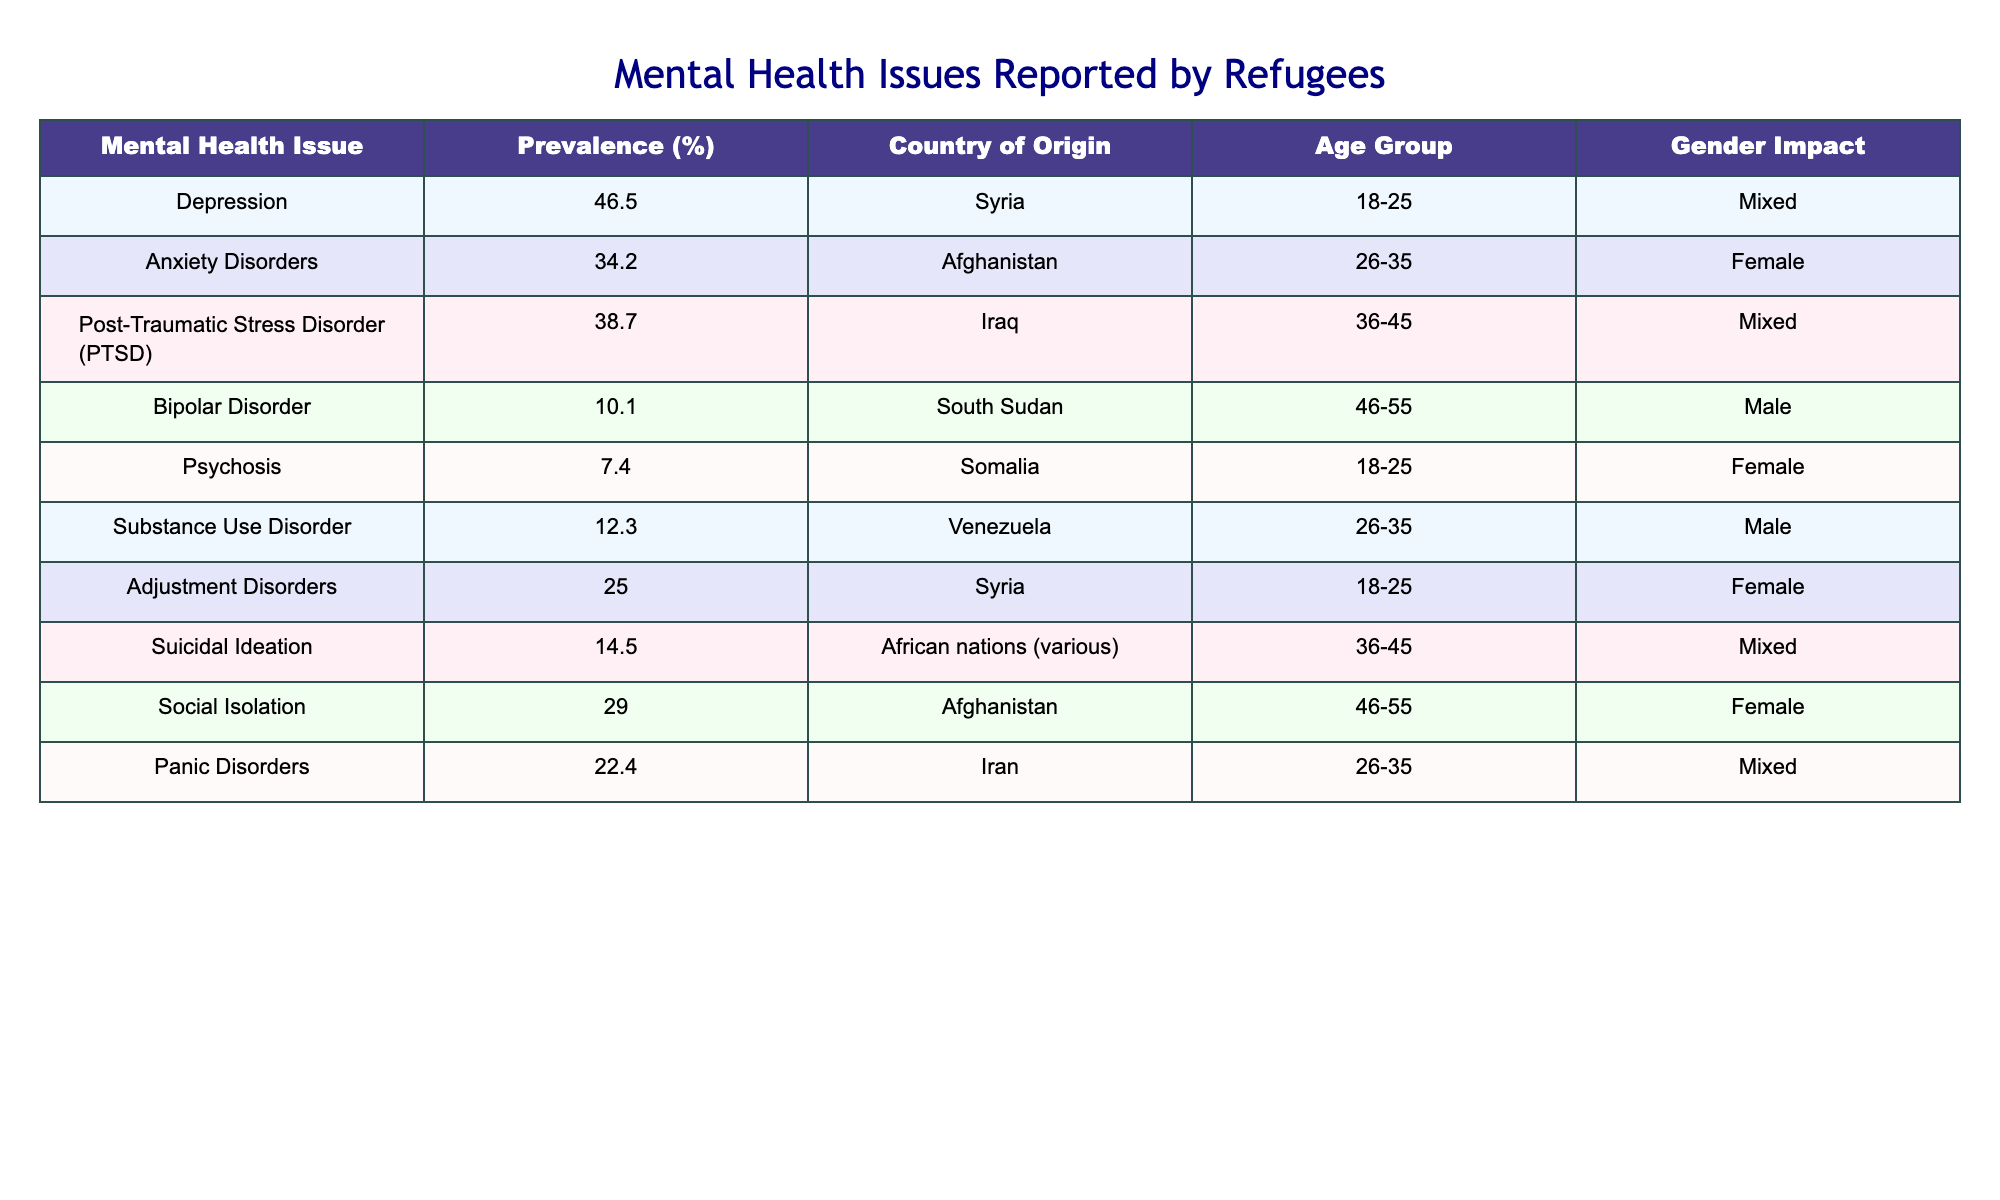What is the prevalence percentage of Depression reported by refugees? The table states that the prevalence percentage of Depression is listed under the "Prevalence (%)" column for Syria. The value next to Depression is 46.5%.
Answer: 46.5% Which age group shows the highest prevalence of Anxiety Disorders? The table shows that Anxiety Disorders have a prevalence of 34.2% for the age group 26-35. This is the only entry for Anxiety Disorders and thus highlights that this age group has the highest prevalence for this specific issue.
Answer: 26-35 Are there any reported cases of Psychosis among males in the age group 18-25? According to the table, Psychosis is reported for the age group 18-25 but specifically for females with a prevalence of 7.4%. There are no entries for males in this age group for Psychosis.
Answer: No What is the total prevalence percentage of Adjustment Disorders and Panic Disorders combined? To find the total prevalence percentage, add the values for Adjustment Disorders (25.0%) and Panic Disorders (22.4%). The calculation is 25.0 + 22.4 = 47.4%.
Answer: 47.4% Which mental health issue has the lowest prevalence and what is the country of origin? The table indicates that Psychosis has the lowest prevalence with a value of 7.4%. The country of origin for this issue is Somalia.
Answer: Psychosis, Somalia Is the prevalence of Substance Use Disorder higher in the age group 26-35 than in age group 46-55? The prevalence for Substance Use Disorder in the age group 26-35 is 12.3%. In comparison, the table shows no specific mention of Substance Use Disorder for the age group 46-55, which indicates that it is higher in the younger age group.
Answer: Yes What percentage of refugees reported Suicidal Ideation and which countries does it affect most? The prevalence of Suicidal Ideation is 14.5%. It is reported among refugees from various African nations, specifically in the age group 36-45.
Answer: 14.5%, African nations (various) How many unique countries are represented in the reported mental health issues? By reviewing the table, there are unique entries for countries: Syria, Afghanistan, Iraq, South Sudan, Somalia, Venezuela, and Iran. Counting these, we have 7 unique countries.
Answer: 7 